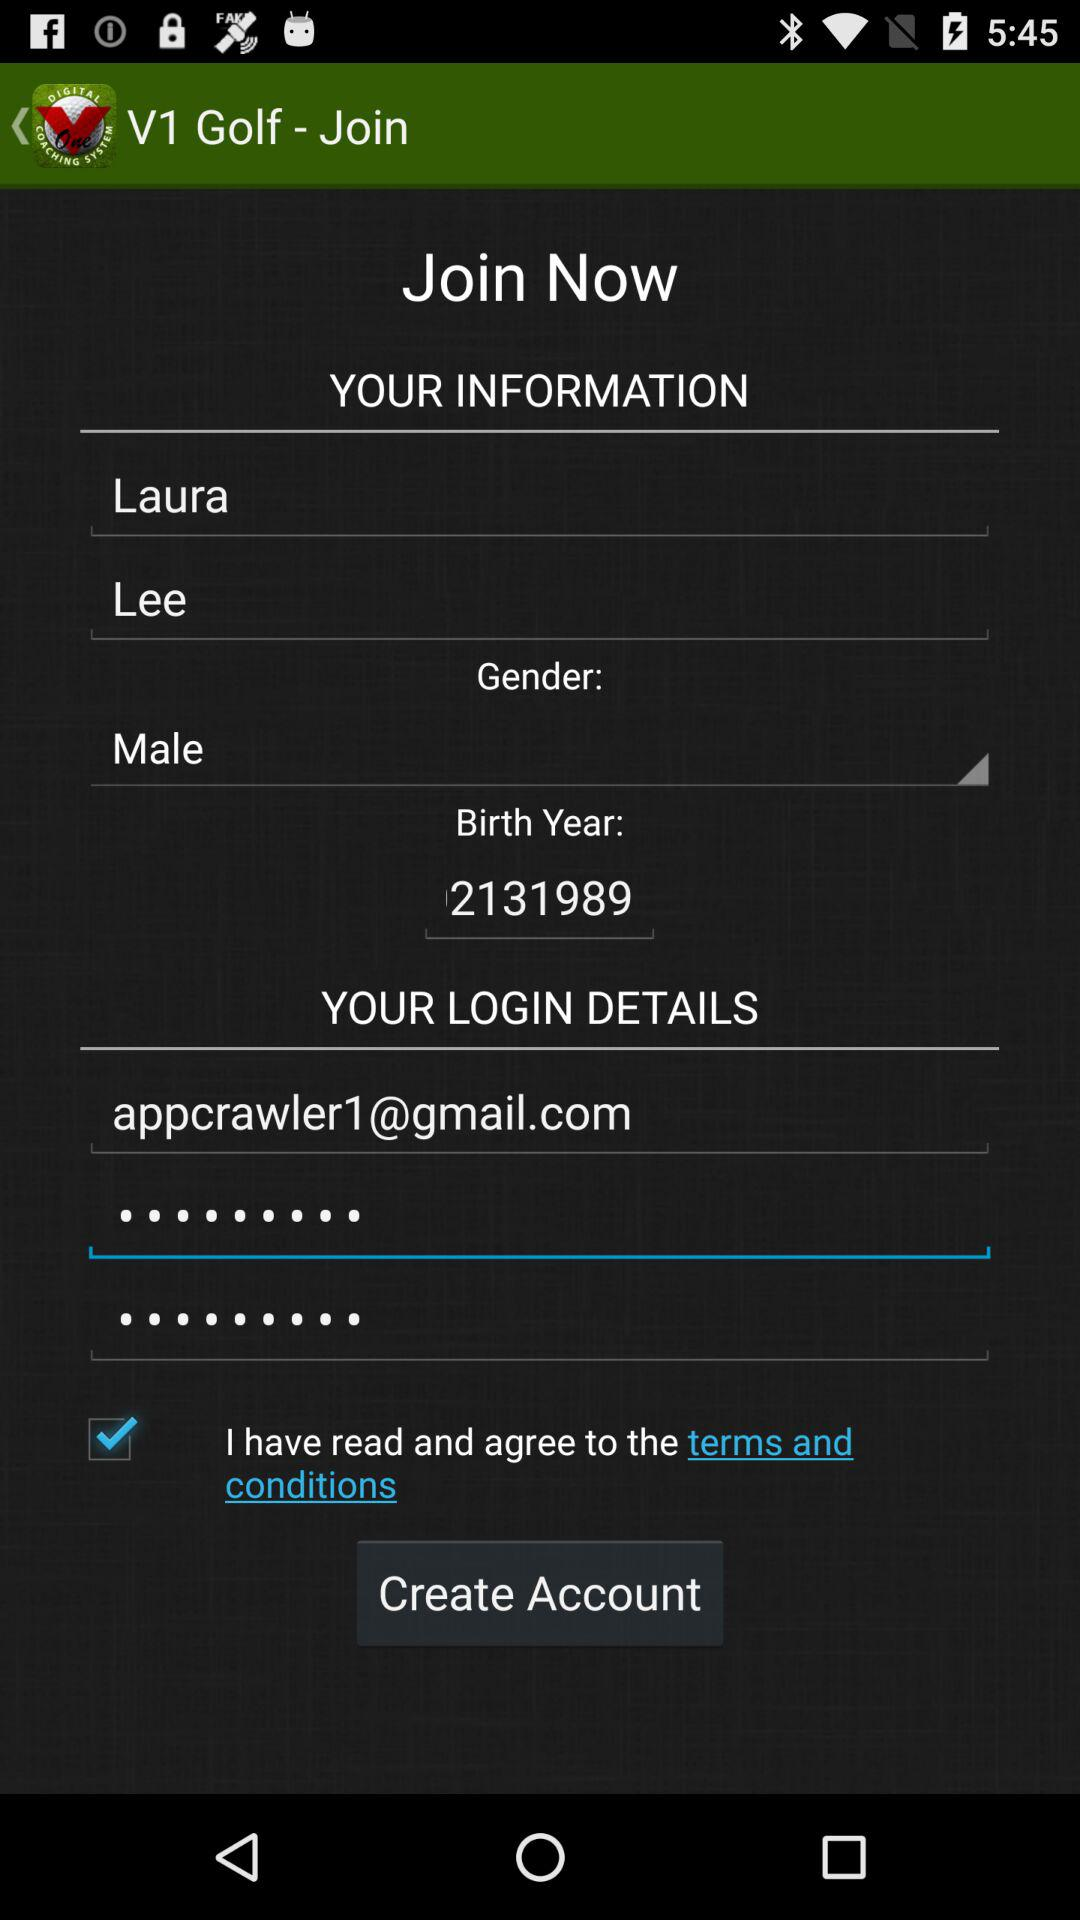Which gender options are available to choose from?
When the provided information is insufficient, respond with <no answer>. <no answer> 